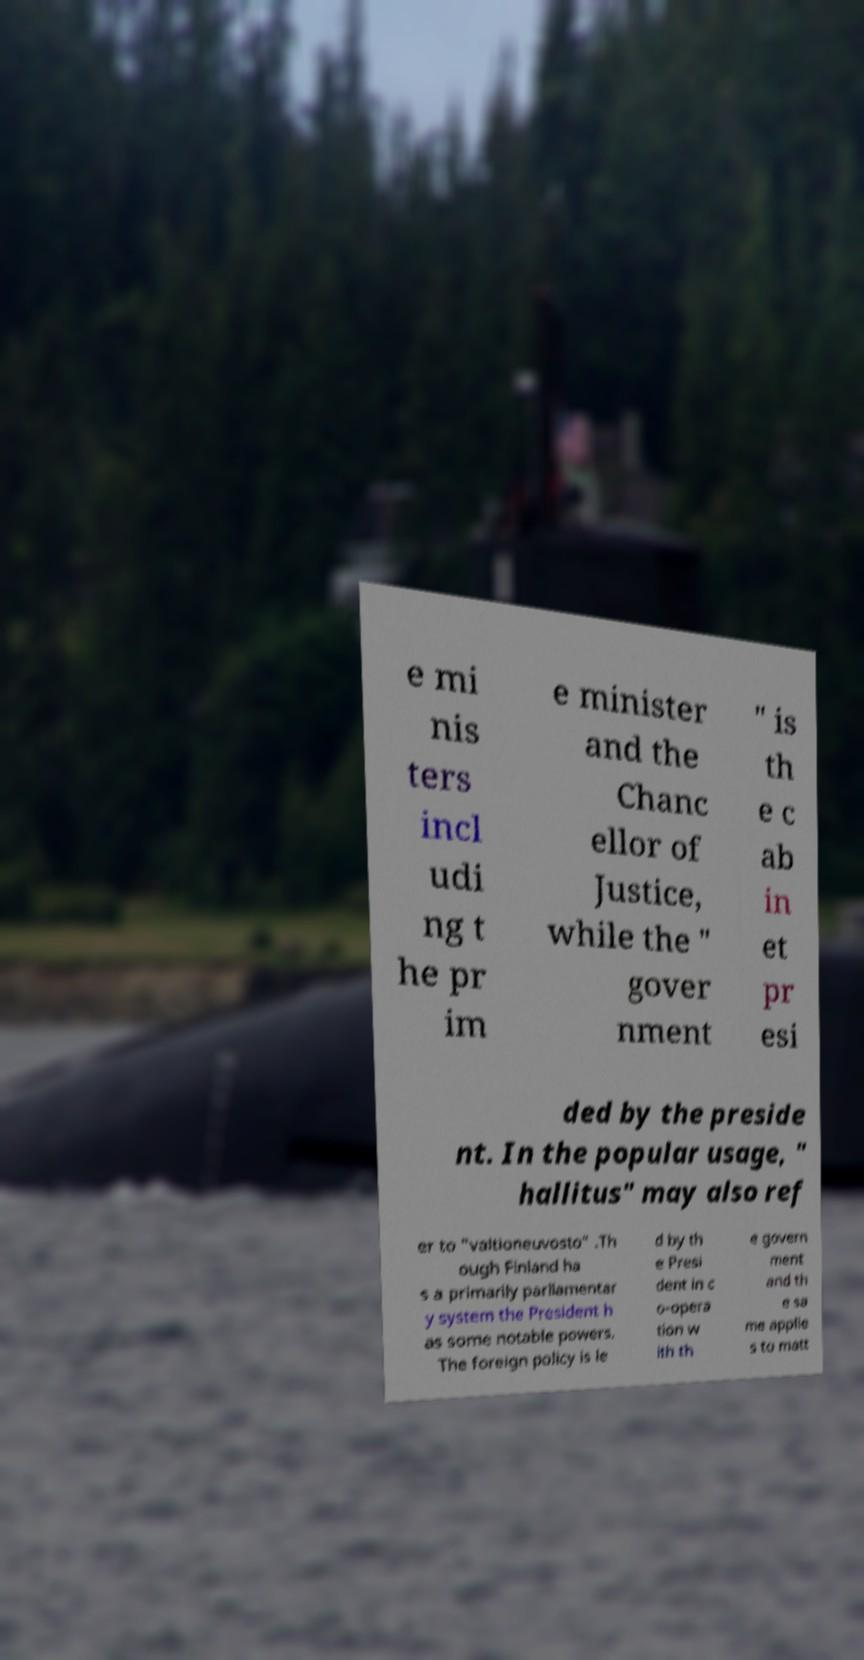There's text embedded in this image that I need extracted. Can you transcribe it verbatim? e mi nis ters incl udi ng t he pr im e minister and the Chanc ellor of Justice, while the " gover nment " is th e c ab in et pr esi ded by the preside nt. In the popular usage, " hallitus" may also ref er to "valtioneuvosto" .Th ough Finland ha s a primarily parliamentar y system the President h as some notable powers. The foreign policy is le d by th e Presi dent in c o-opera tion w ith th e govern ment and th e sa me applie s to matt 